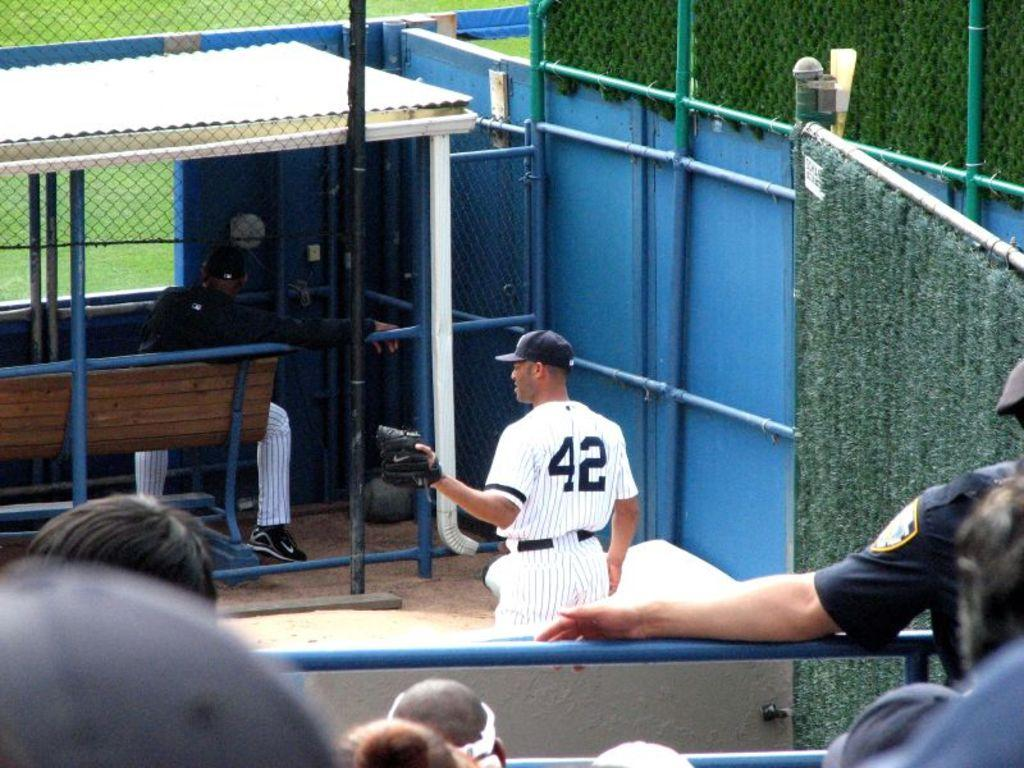How many people are in the image? There are people in the image, but the exact number is not specified. What is the person sitting on in the image? There is a bench in the image, and a person is sitting on it. What are the rods and mesh used for in the image? The purpose of the rods and mesh is not specified in the facts provided. What type of vegetation is visible in the image? Grass is visible in the image. What is the person wearing on their head? A person is wearing a cap in the image. Where are the human heads located in the image? Human heads are visible at the bottom of the image. What type of cherry is being used to extinguish the flame on the juice in the image? There is no cherry, flame, or juice present in the image. 